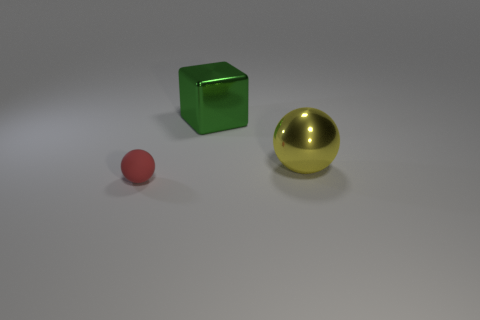Are there the same number of shiny balls that are in front of the small red object and big spheres that are behind the green metal block?
Give a very brief answer. Yes. Is the number of large yellow spheres that are behind the yellow metallic sphere greater than the number of green shiny things?
Your response must be concise. No. How many things are large things behind the big yellow shiny object or green metal spheres?
Provide a succinct answer. 1. How many green blocks have the same material as the yellow thing?
Your response must be concise. 1. Is there a yellow metallic thing that has the same shape as the green object?
Make the answer very short. No. What is the shape of the yellow object that is the same size as the green thing?
Your answer should be very brief. Sphere. Is the color of the matte ball the same as the thing right of the large green metal object?
Your answer should be compact. No. There is a big shiny thing in front of the cube; what number of small rubber spheres are behind it?
Your answer should be very brief. 0. There is a object that is both in front of the large green cube and to the right of the tiny red matte thing; how big is it?
Provide a short and direct response. Large. Is there a green metallic thing of the same size as the red rubber ball?
Ensure brevity in your answer.  No. 